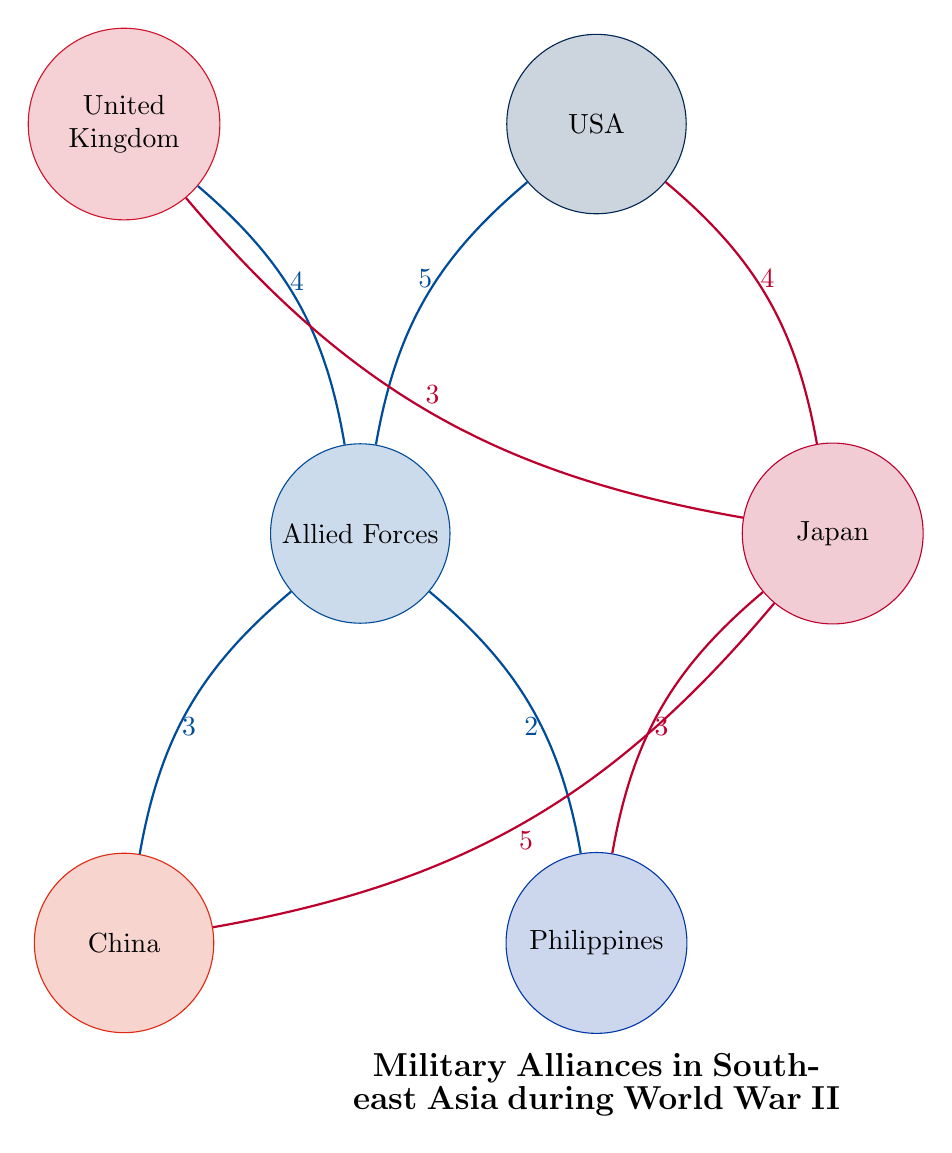What is the connection value between Allied Forces and the USA? In the diagram, there is a direct link from the Allied Forces to the USA, and the associated value is specified as 5.
Answer: 5 What is the total number of nodes present in this diagram? By counting the circles representing different entities in the diagram, we find there are 6 nodes in total: Allied Forces, Japan, USA, United Kingdom, China, and Philippines.
Answer: 6 Which country has the highest connection value with Japan? Examining the links from Japan, we see that the connection to China has the highest value of 5, making China the strongest connection for Japan.
Answer: China What is the connection value between Japan and the UK? In the diagram, the connection from Japan to the United Kingdom is represented with a value of 3.
Answer: 3 Which country has the lowest connection with the Allied Forces? Looking at the links from the Allied Forces, we see that the Philippines has the lowest connection value of 2 among the listed connections.
Answer: Philippines How many connections do the Allied Forces have total? To find the total connections from the Allied Forces, we add the values of all the links: 5 (USA) + 4 (UK) + 3 (China) + 2 (Philippines) = 14 in total.
Answer: 14 What is the connection value between Japan and the Philippines? The diagram shows a connection from Japan to the Philippines, and the associated value is 3.
Answer: 3 Which entity is connected to both the USA and the UK through the Allied Forces? The Allied Forces serve as the link to both countries, with connections to USA (5) and UK (4). Hence, the entity bridging both connections is Allied Forces.
Answer: Allied Forces Which country has the strongest military alliance in the diagram based on total connection values? By analyzing the connection values for each country, we find that Japan has the strongest total of connections: 4 (USA) + 3 (UK) + 5 (China) + 3 (Philippines) = 15.
Answer: Japan 